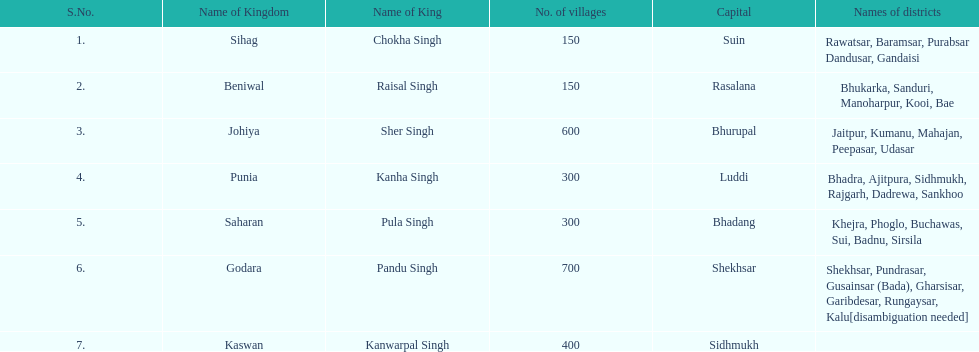How many realms are listed? 7. 